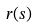Convert formula to latex. <formula><loc_0><loc_0><loc_500><loc_500>r ( s )</formula> 